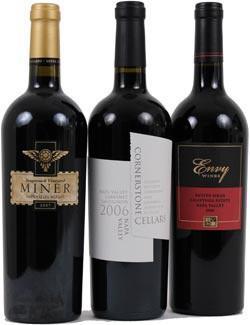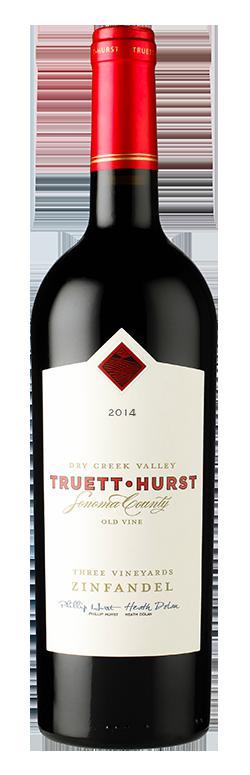The first image is the image on the left, the second image is the image on the right. Analyze the images presented: Is the assertion "There are fewer than 4 bottles across both images." valid? Answer yes or no. No. The first image is the image on the left, the second image is the image on the right. For the images shown, is this caption "One image contains a horizontal row of three wine bottles." true? Answer yes or no. Yes. 